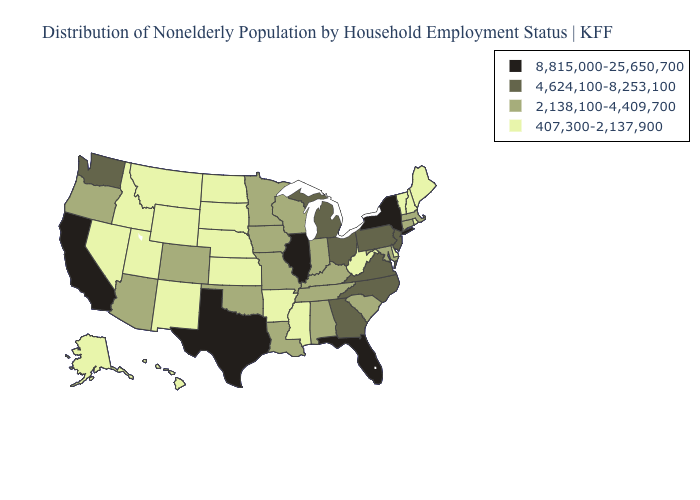What is the highest value in states that border Alabama?
Concise answer only. 8,815,000-25,650,700. What is the value of Alabama?
Write a very short answer. 2,138,100-4,409,700. What is the highest value in the South ?
Be succinct. 8,815,000-25,650,700. Does Mississippi have the lowest value in the USA?
Answer briefly. Yes. Does Arizona have a higher value than Connecticut?
Keep it brief. No. Name the states that have a value in the range 407,300-2,137,900?
Be succinct. Alaska, Arkansas, Delaware, Hawaii, Idaho, Kansas, Maine, Mississippi, Montana, Nebraska, Nevada, New Hampshire, New Mexico, North Dakota, Rhode Island, South Dakota, Utah, Vermont, West Virginia, Wyoming. What is the value of Arkansas?
Concise answer only. 407,300-2,137,900. Does Maryland have a higher value than Mississippi?
Keep it brief. Yes. Among the states that border Wyoming , does South Dakota have the lowest value?
Keep it brief. Yes. What is the lowest value in states that border Kansas?
Give a very brief answer. 407,300-2,137,900. What is the highest value in states that border Kentucky?
Short answer required. 8,815,000-25,650,700. Name the states that have a value in the range 8,815,000-25,650,700?
Quick response, please. California, Florida, Illinois, New York, Texas. Name the states that have a value in the range 4,624,100-8,253,100?
Keep it brief. Georgia, Michigan, New Jersey, North Carolina, Ohio, Pennsylvania, Virginia, Washington. Name the states that have a value in the range 4,624,100-8,253,100?
Answer briefly. Georgia, Michigan, New Jersey, North Carolina, Ohio, Pennsylvania, Virginia, Washington. 